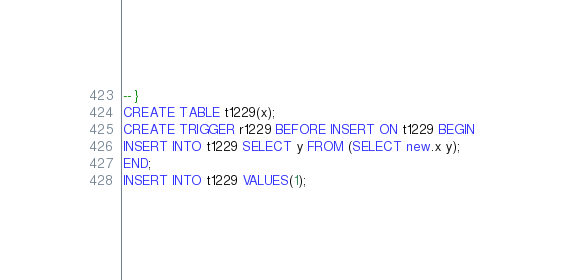Convert code to text. <code><loc_0><loc_0><loc_500><loc_500><_SQL_>-- }
CREATE TABLE t1229(x);
CREATE TRIGGER r1229 BEFORE INSERT ON t1229 BEGIN
INSERT INTO t1229 SELECT y FROM (SELECT new.x y);
END;
INSERT INTO t1229 VALUES(1);</code> 